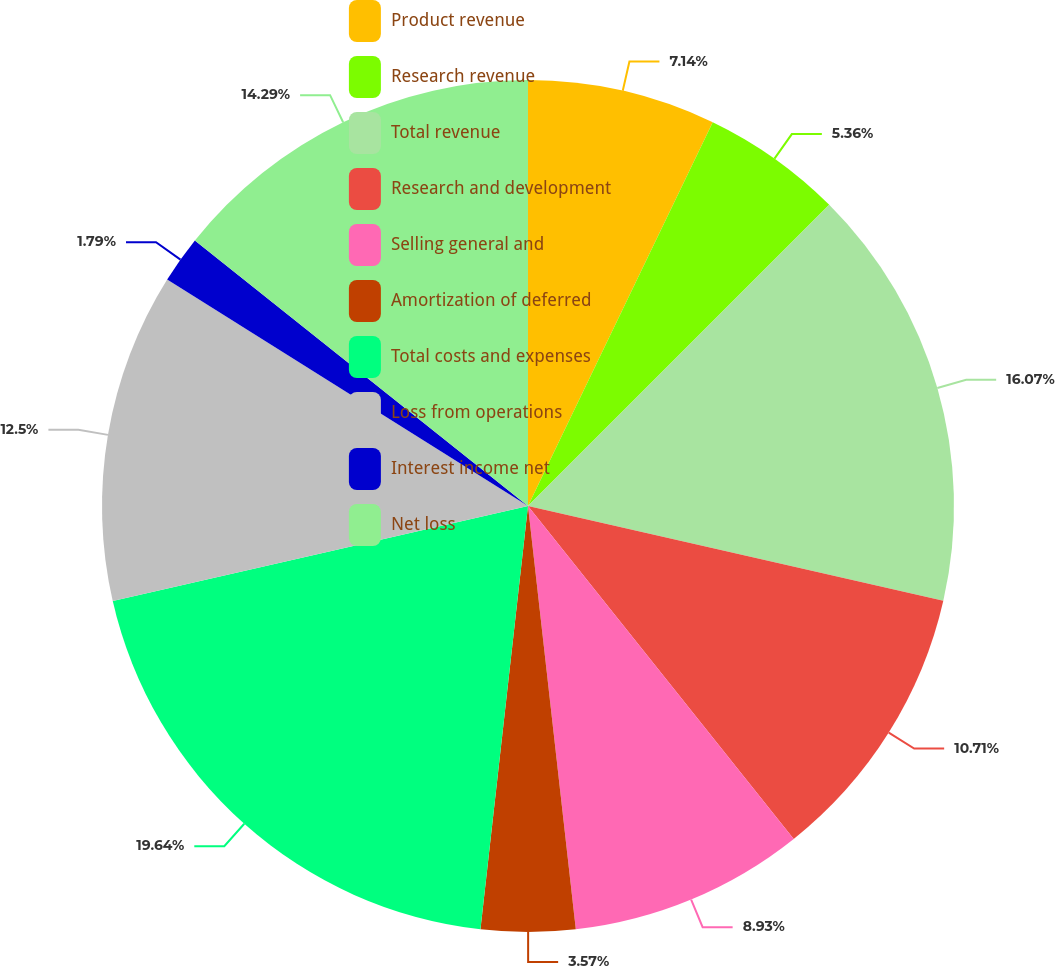<chart> <loc_0><loc_0><loc_500><loc_500><pie_chart><fcel>Product revenue<fcel>Research revenue<fcel>Total revenue<fcel>Research and development<fcel>Selling general and<fcel>Amortization of deferred<fcel>Total costs and expenses<fcel>Loss from operations<fcel>Interest income net<fcel>Net loss<nl><fcel>7.14%<fcel>5.36%<fcel>16.07%<fcel>10.71%<fcel>8.93%<fcel>3.57%<fcel>19.64%<fcel>12.5%<fcel>1.79%<fcel>14.29%<nl></chart> 